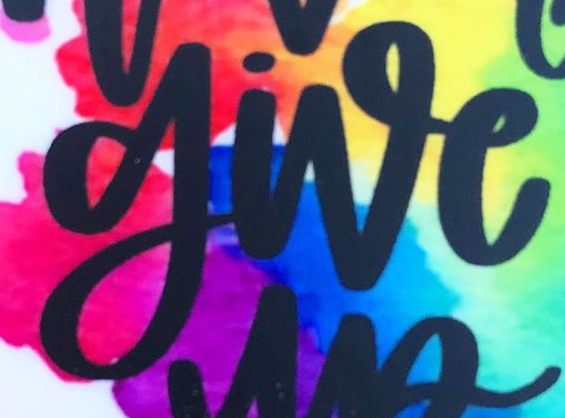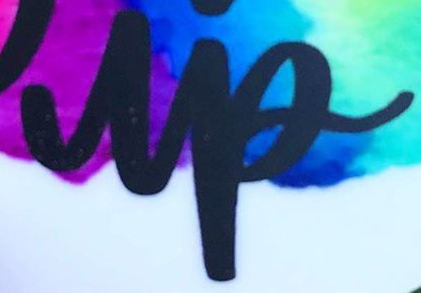What text is displayed in these images sequentially, separated by a semicolon? give; up 